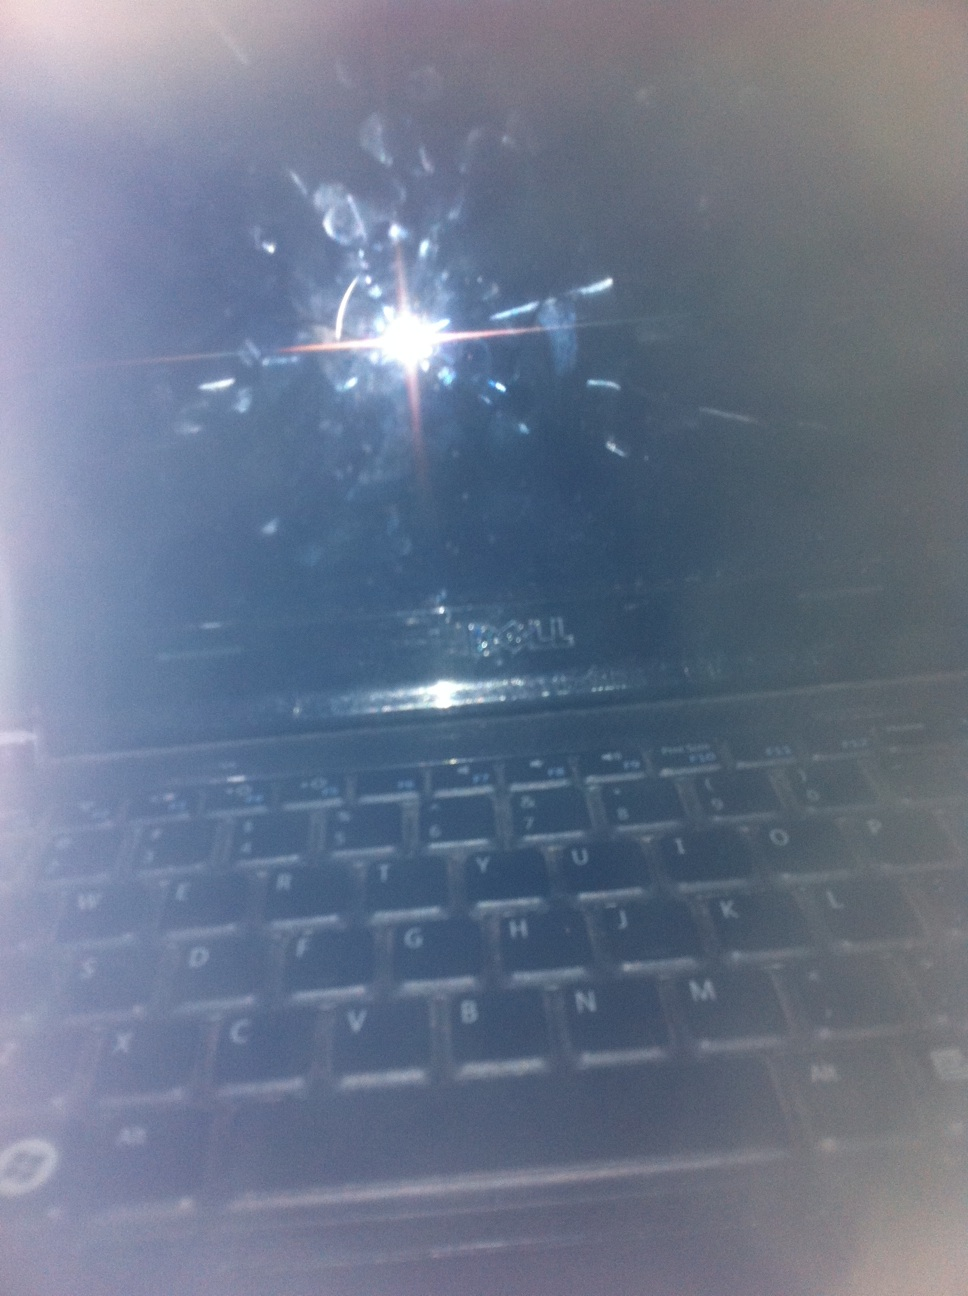Create a short scenario in which this laptop plays a critical role in a cyber thriller. The room is dark, illuminated only by the dim glow of a single lamp in the corner. On the desk sits the laptop, seemingly innocuous. A seasoned hacker types feverishly, each keystroke drawing them closer to uncovering a massive conspiracy. The smudges on the screen are a testament to countless hours of relentless searching. Suddenly, the laptop lights up, displaying a complex algorithm that starts decrypting files, revealing the hidden connections between global power brokers and an upcoming catastrophic event. 